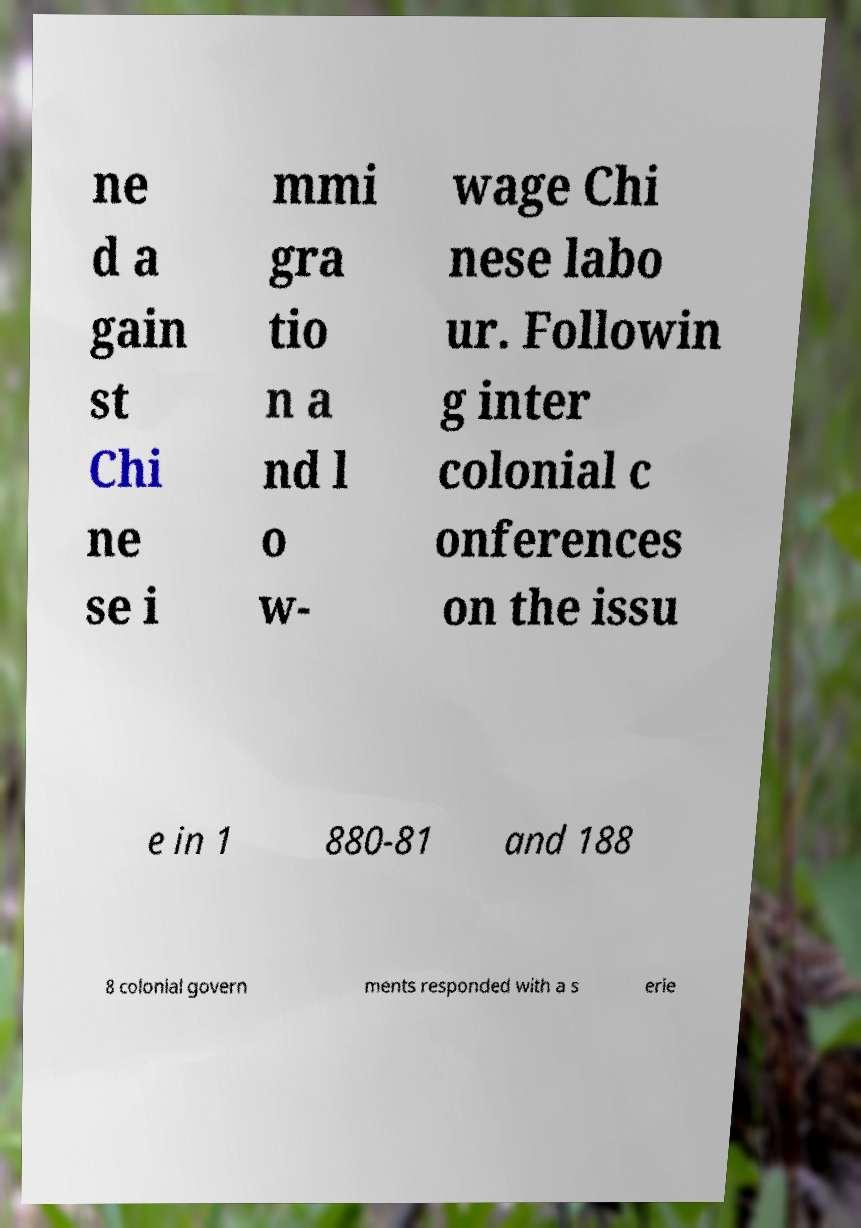There's text embedded in this image that I need extracted. Can you transcribe it verbatim? ne d a gain st Chi ne se i mmi gra tio n a nd l o w- wage Chi nese labo ur. Followin g inter colonial c onferences on the issu e in 1 880-81 and 188 8 colonial govern ments responded with a s erie 